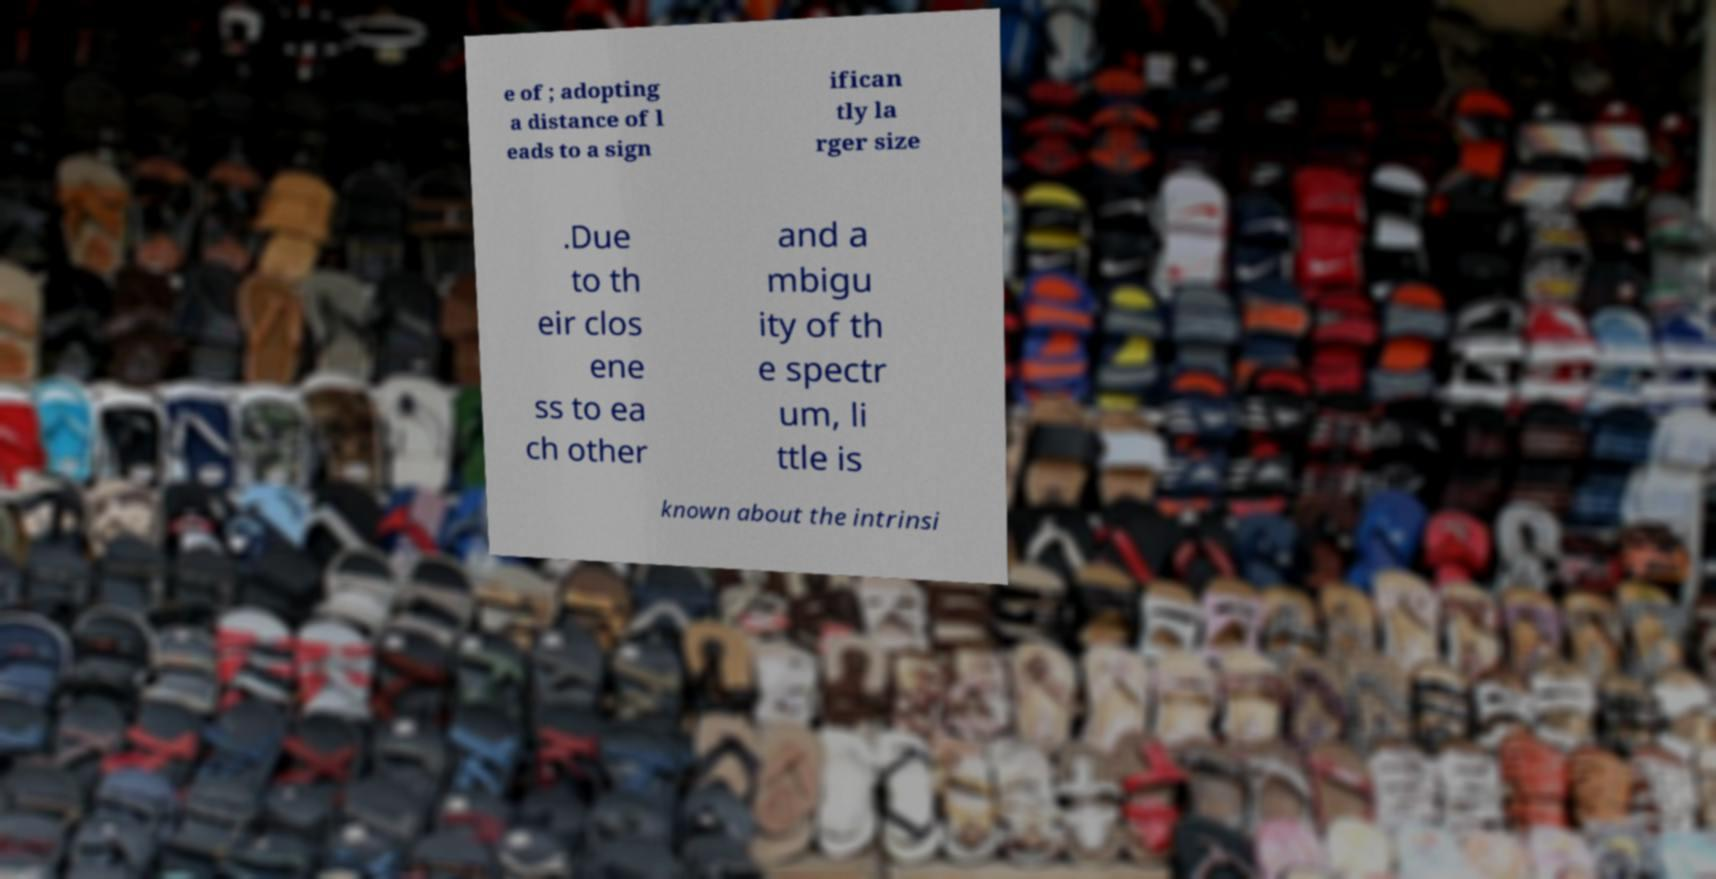Please read and relay the text visible in this image. What does it say? e of ; adopting a distance of l eads to a sign ifican tly la rger size .Due to th eir clos ene ss to ea ch other and a mbigu ity of th e spectr um, li ttle is known about the intrinsi 